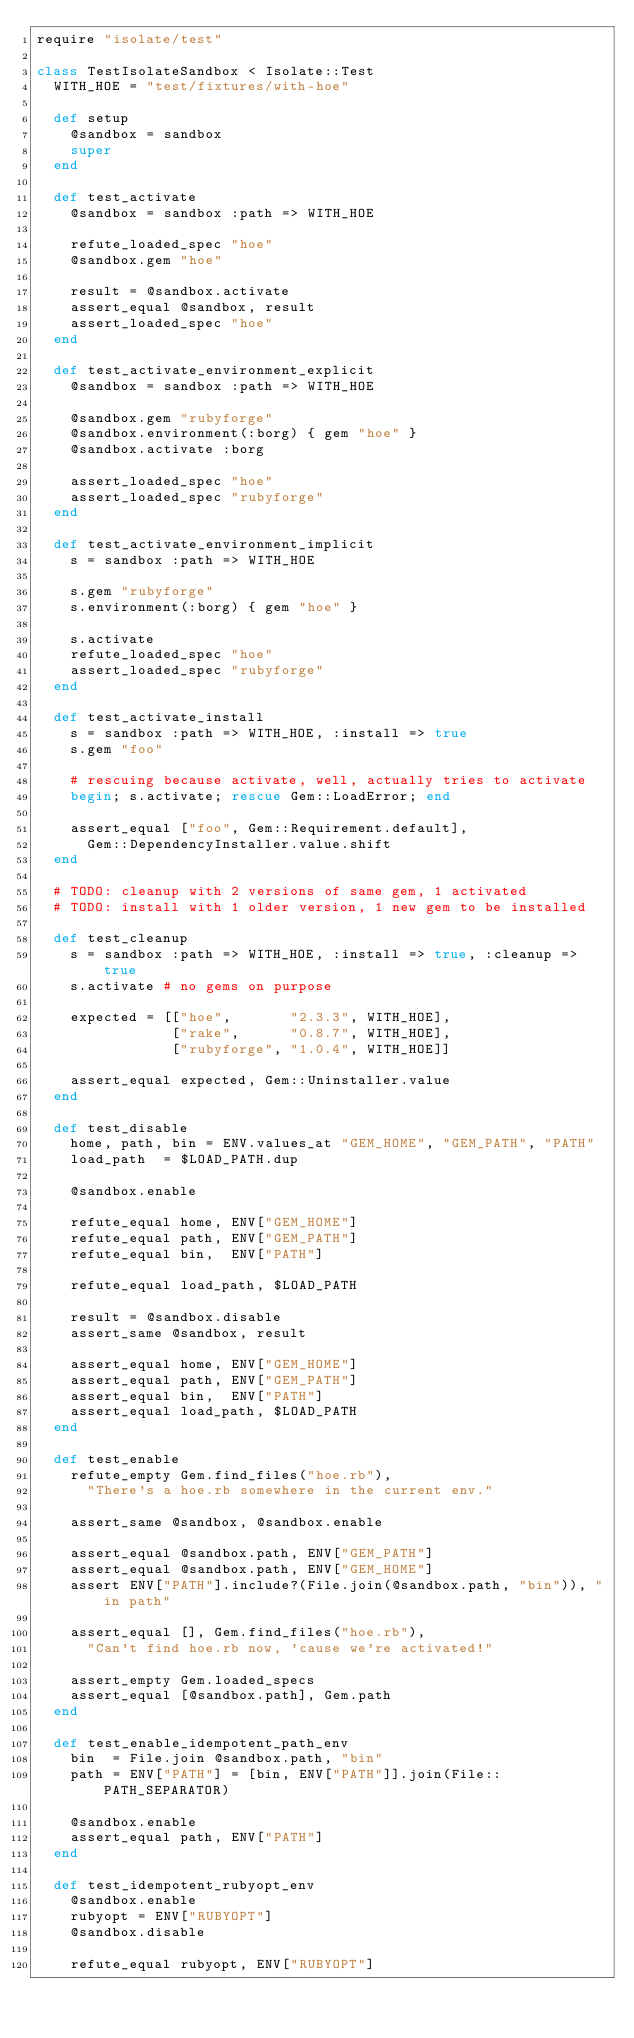<code> <loc_0><loc_0><loc_500><loc_500><_Ruby_>require "isolate/test"

class TestIsolateSandbox < Isolate::Test
  WITH_HOE = "test/fixtures/with-hoe"

  def setup
    @sandbox = sandbox
    super
  end

  def test_activate
    @sandbox = sandbox :path => WITH_HOE

    refute_loaded_spec "hoe"
    @sandbox.gem "hoe"

    result = @sandbox.activate
    assert_equal @sandbox, result
    assert_loaded_spec "hoe"
  end

  def test_activate_environment_explicit
    @sandbox = sandbox :path => WITH_HOE

    @sandbox.gem "rubyforge"
    @sandbox.environment(:borg) { gem "hoe" }
    @sandbox.activate :borg

    assert_loaded_spec "hoe"
    assert_loaded_spec "rubyforge"
  end

  def test_activate_environment_implicit
    s = sandbox :path => WITH_HOE

    s.gem "rubyforge"
    s.environment(:borg) { gem "hoe" }

    s.activate
    refute_loaded_spec "hoe"
    assert_loaded_spec "rubyforge"
  end

  def test_activate_install
    s = sandbox :path => WITH_HOE, :install => true
    s.gem "foo"

    # rescuing because activate, well, actually tries to activate
    begin; s.activate; rescue Gem::LoadError; end

    assert_equal ["foo", Gem::Requirement.default],
      Gem::DependencyInstaller.value.shift
  end

  # TODO: cleanup with 2 versions of same gem, 1 activated
  # TODO: install with 1 older version, 1 new gem to be installed

  def test_cleanup
    s = sandbox :path => WITH_HOE, :install => true, :cleanup => true
    s.activate # no gems on purpose

    expected = [["hoe",       "2.3.3", WITH_HOE],
                ["rake",      "0.8.7", WITH_HOE],
                ["rubyforge", "1.0.4", WITH_HOE]]

    assert_equal expected, Gem::Uninstaller.value
  end

  def test_disable
    home, path, bin = ENV.values_at "GEM_HOME", "GEM_PATH", "PATH"
    load_path  = $LOAD_PATH.dup

    @sandbox.enable

    refute_equal home, ENV["GEM_HOME"]
    refute_equal path, ENV["GEM_PATH"]
    refute_equal bin,  ENV["PATH"]

    refute_equal load_path, $LOAD_PATH

    result = @sandbox.disable
    assert_same @sandbox, result

    assert_equal home, ENV["GEM_HOME"]
    assert_equal path, ENV["GEM_PATH"]
    assert_equal bin,  ENV["PATH"]
    assert_equal load_path, $LOAD_PATH
  end

  def test_enable
    refute_empty Gem.find_files("hoe.rb"),
      "There's a hoe.rb somewhere in the current env."

    assert_same @sandbox, @sandbox.enable

    assert_equal @sandbox.path, ENV["GEM_PATH"]
    assert_equal @sandbox.path, ENV["GEM_HOME"]
    assert ENV["PATH"].include?(File.join(@sandbox.path, "bin")), "in path"

    assert_equal [], Gem.find_files("hoe.rb"),
      "Can't find hoe.rb now, 'cause we're activated!"

    assert_empty Gem.loaded_specs
    assert_equal [@sandbox.path], Gem.path
  end

  def test_enable_idempotent_path_env
    bin  = File.join @sandbox.path, "bin"
    path = ENV["PATH"] = [bin, ENV["PATH"]].join(File::PATH_SEPARATOR)

    @sandbox.enable
    assert_equal path, ENV["PATH"]
  end

  def test_idempotent_rubyopt_env
    @sandbox.enable
    rubyopt = ENV["RUBYOPT"]
    @sandbox.disable

    refute_equal rubyopt, ENV["RUBYOPT"]
</code> 